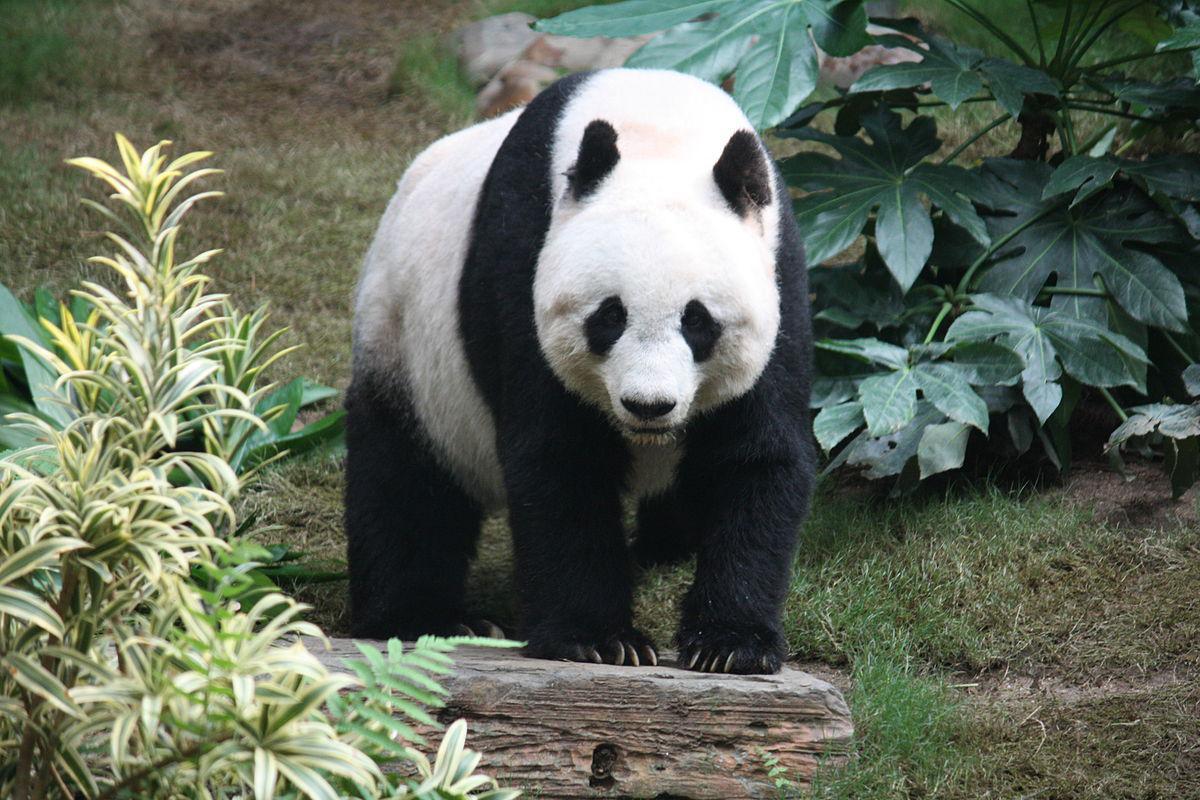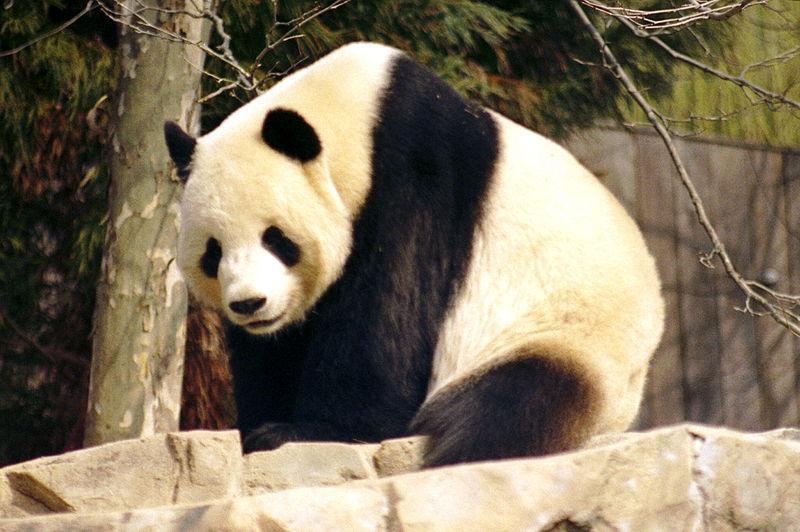The first image is the image on the left, the second image is the image on the right. Examine the images to the left and right. Is the description "An image shows exactly one panda, and it has an opened mouth." accurate? Answer yes or no. No. The first image is the image on the left, the second image is the image on the right. Assess this claim about the two images: "A single panda is in one image with its mouth open, showing the pink interior and some teeth.". Correct or not? Answer yes or no. No. 